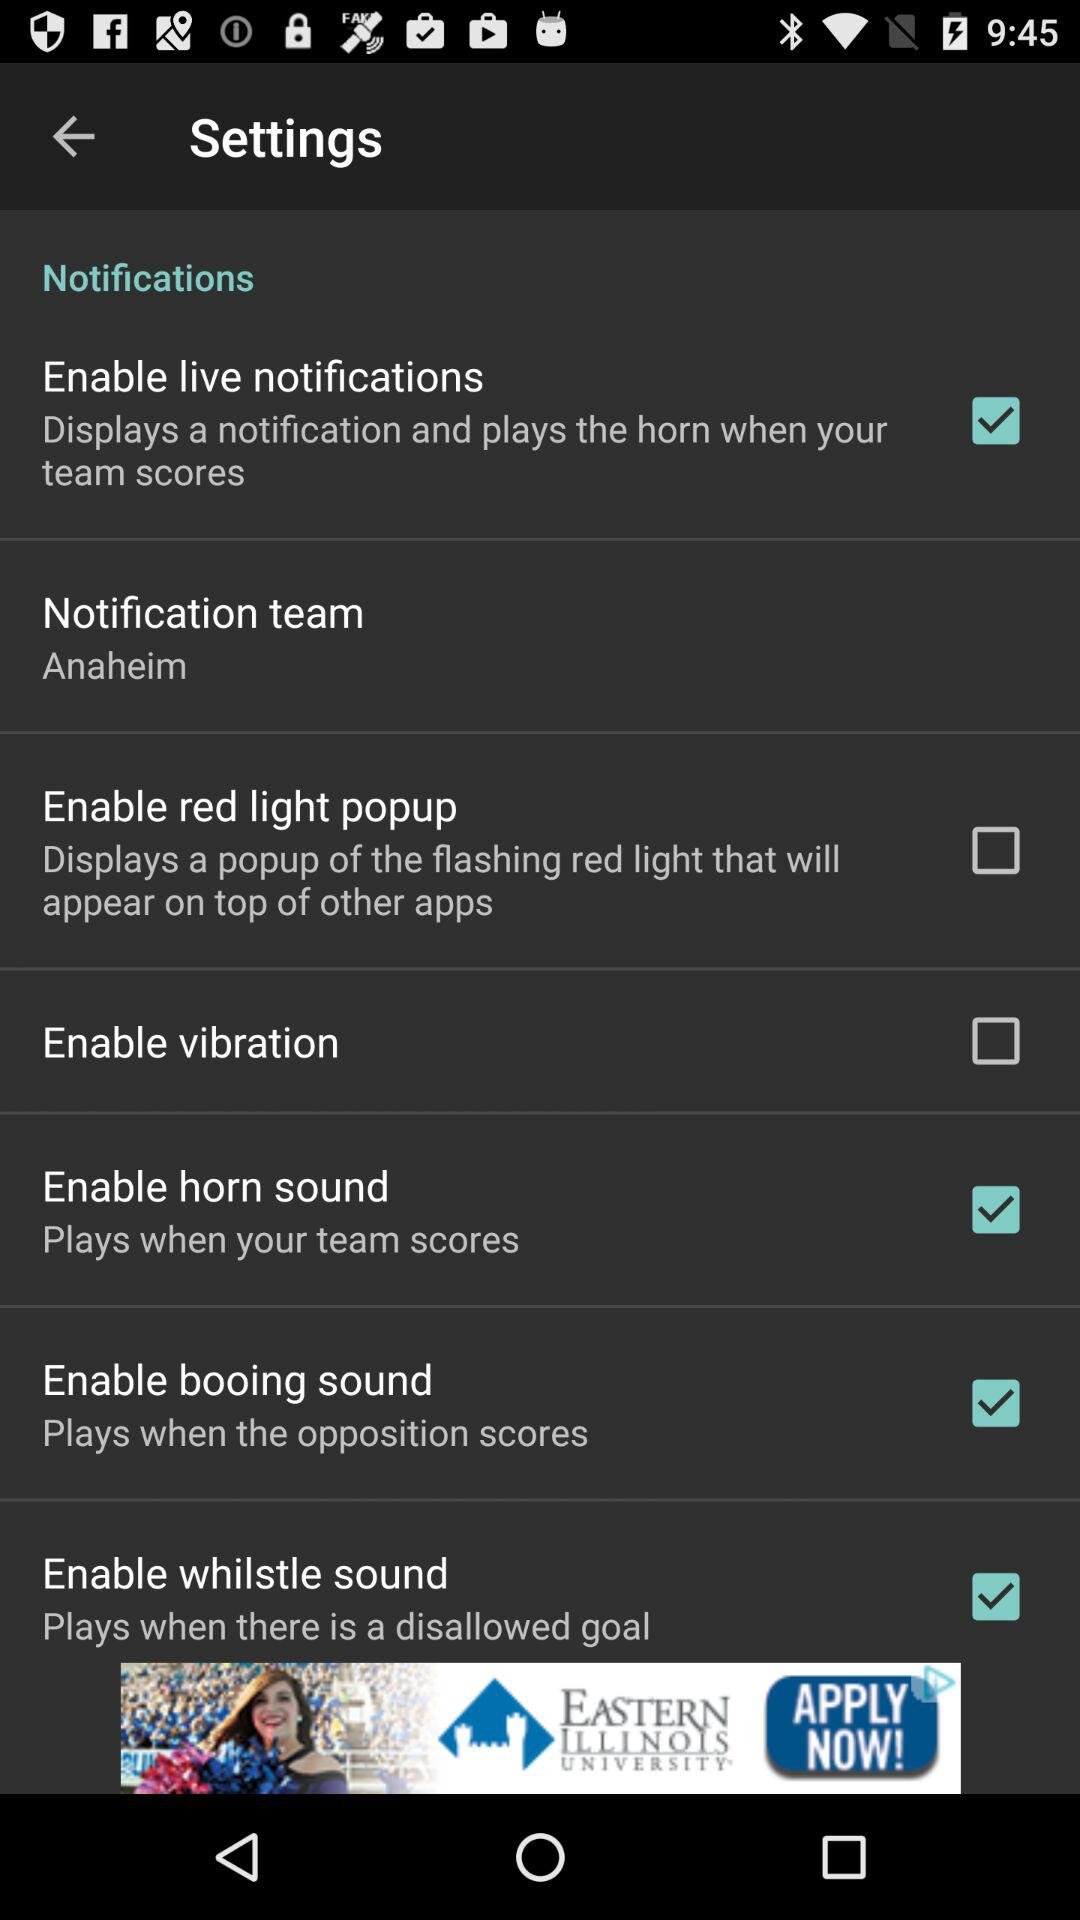What are the checked settings? The checked settings are "Enable live notifications", "Enable horn sound", "Enable booing sound" and "Enable whilstle sound". 